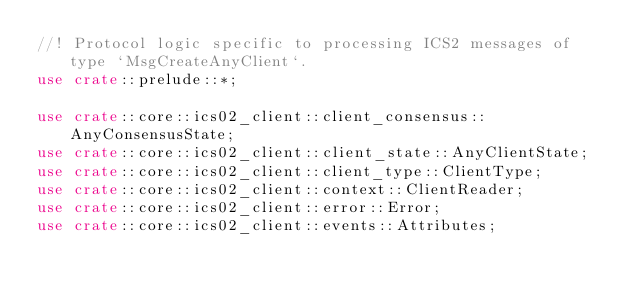<code> <loc_0><loc_0><loc_500><loc_500><_Rust_>//! Protocol logic specific to processing ICS2 messages of type `MsgCreateAnyClient`.
use crate::prelude::*;

use crate::core::ics02_client::client_consensus::AnyConsensusState;
use crate::core::ics02_client::client_state::AnyClientState;
use crate::core::ics02_client::client_type::ClientType;
use crate::core::ics02_client::context::ClientReader;
use crate::core::ics02_client::error::Error;
use crate::core::ics02_client::events::Attributes;</code> 